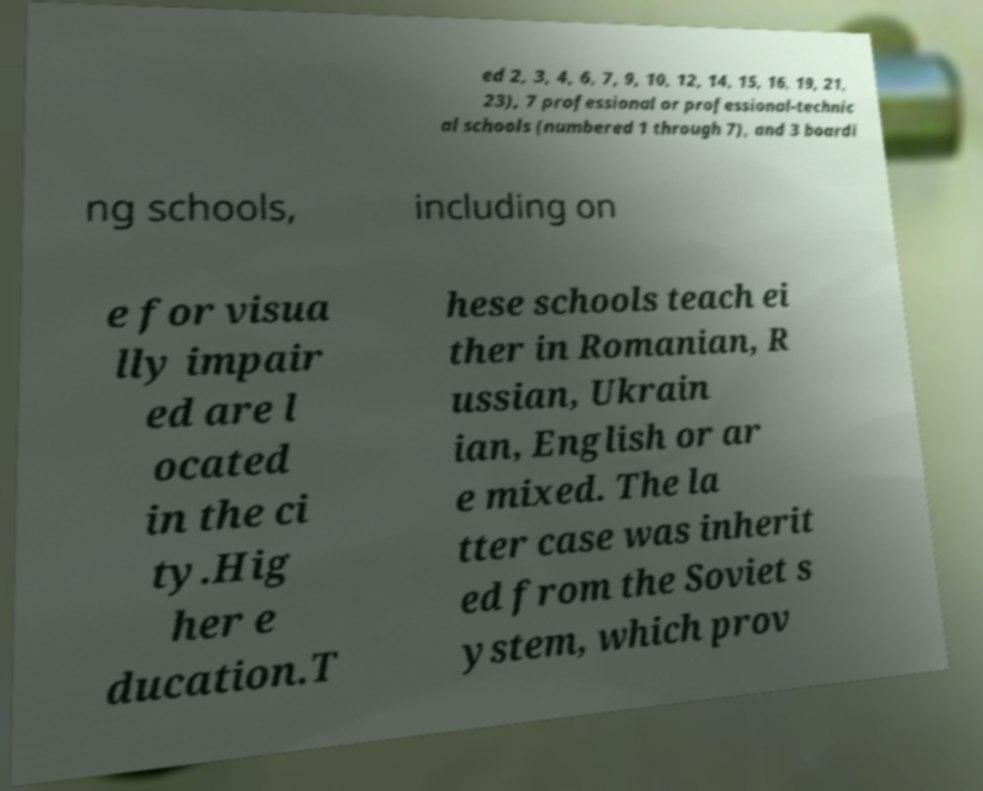Could you extract and type out the text from this image? ed 2, 3, 4, 6, 7, 9, 10, 12, 14, 15, 16, 19, 21, 23), 7 professional or professional-technic al schools (numbered 1 through 7), and 3 boardi ng schools, including on e for visua lly impair ed are l ocated in the ci ty.Hig her e ducation.T hese schools teach ei ther in Romanian, R ussian, Ukrain ian, English or ar e mixed. The la tter case was inherit ed from the Soviet s ystem, which prov 